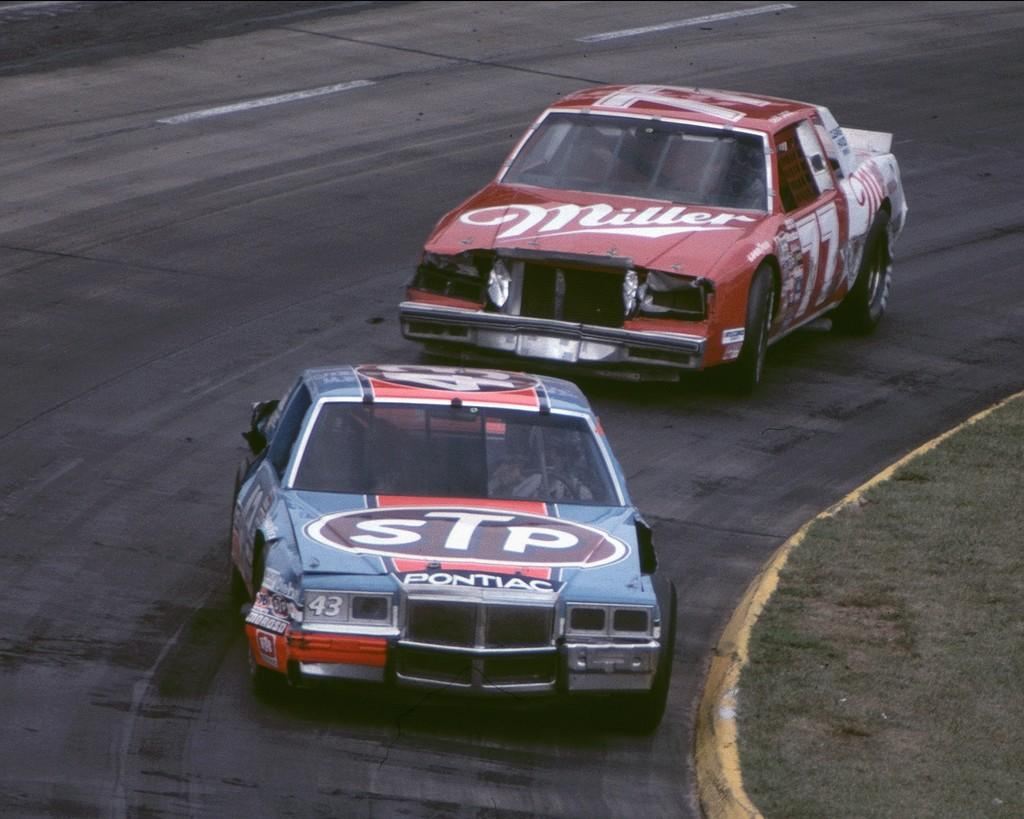How many cars are visible in the image? There are two cars in the image. Where are the cars located? The cars are on the road in the image. How are the cars positioned in relation to each other? The cars are one behind the other in the image. What type of vegetation can be seen on the footpath? There is grass on the footpath in the image. What type of battle is taking place in the image? There is no battle present in the image; it features two cars on the road. Can you tell me where the harbor is located in the image? There is no harbor present in the image; it only shows two cars on the road and grass on the footpath. 